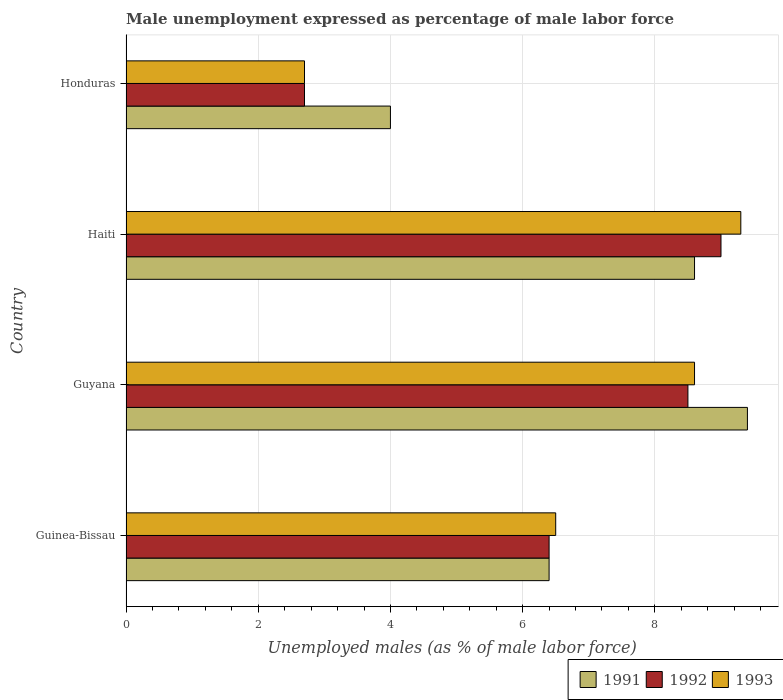How many different coloured bars are there?
Give a very brief answer. 3. How many groups of bars are there?
Offer a terse response. 4. Are the number of bars per tick equal to the number of legend labels?
Ensure brevity in your answer.  Yes. Are the number of bars on each tick of the Y-axis equal?
Offer a terse response. Yes. How many bars are there on the 2nd tick from the top?
Offer a very short reply. 3. How many bars are there on the 3rd tick from the bottom?
Offer a terse response. 3. What is the label of the 1st group of bars from the top?
Keep it short and to the point. Honduras. In how many cases, is the number of bars for a given country not equal to the number of legend labels?
Your answer should be very brief. 0. What is the unemployment in males in in 1992 in Guyana?
Give a very brief answer. 8.5. Across all countries, what is the maximum unemployment in males in in 1991?
Make the answer very short. 9.4. In which country was the unemployment in males in in 1991 maximum?
Your answer should be compact. Guyana. In which country was the unemployment in males in in 1993 minimum?
Ensure brevity in your answer.  Honduras. What is the total unemployment in males in in 1993 in the graph?
Ensure brevity in your answer.  27.1. What is the difference between the unemployment in males in in 1993 in Guinea-Bissau and that in Guyana?
Your answer should be very brief. -2.1. What is the difference between the unemployment in males in in 1991 in Guyana and the unemployment in males in in 1993 in Honduras?
Make the answer very short. 6.7. What is the average unemployment in males in in 1993 per country?
Give a very brief answer. 6.78. What is the difference between the unemployment in males in in 1993 and unemployment in males in in 1992 in Guyana?
Your response must be concise. 0.1. In how many countries, is the unemployment in males in in 1992 greater than 3.2 %?
Your answer should be compact. 3. What is the ratio of the unemployment in males in in 1993 in Haiti to that in Honduras?
Your answer should be compact. 3.44. Is the unemployment in males in in 1991 in Guinea-Bissau less than that in Honduras?
Offer a terse response. No. Is the difference between the unemployment in males in in 1993 in Haiti and Honduras greater than the difference between the unemployment in males in in 1992 in Haiti and Honduras?
Your answer should be compact. Yes. What is the difference between the highest and the lowest unemployment in males in in 1993?
Your answer should be compact. 6.6. Is the sum of the unemployment in males in in 1993 in Guinea-Bissau and Guyana greater than the maximum unemployment in males in in 1991 across all countries?
Keep it short and to the point. Yes. What does the 2nd bar from the top in Haiti represents?
Your answer should be compact. 1992. What does the 3rd bar from the bottom in Honduras represents?
Make the answer very short. 1993. Are all the bars in the graph horizontal?
Offer a very short reply. Yes. Are the values on the major ticks of X-axis written in scientific E-notation?
Offer a terse response. No. Does the graph contain grids?
Offer a terse response. Yes. Where does the legend appear in the graph?
Ensure brevity in your answer.  Bottom right. How many legend labels are there?
Keep it short and to the point. 3. What is the title of the graph?
Offer a very short reply. Male unemployment expressed as percentage of male labor force. What is the label or title of the X-axis?
Keep it short and to the point. Unemployed males (as % of male labor force). What is the label or title of the Y-axis?
Offer a very short reply. Country. What is the Unemployed males (as % of male labor force) in 1991 in Guinea-Bissau?
Make the answer very short. 6.4. What is the Unemployed males (as % of male labor force) of 1992 in Guinea-Bissau?
Keep it short and to the point. 6.4. What is the Unemployed males (as % of male labor force) of 1993 in Guinea-Bissau?
Offer a very short reply. 6.5. What is the Unemployed males (as % of male labor force) in 1991 in Guyana?
Your answer should be very brief. 9.4. What is the Unemployed males (as % of male labor force) of 1993 in Guyana?
Ensure brevity in your answer.  8.6. What is the Unemployed males (as % of male labor force) of 1991 in Haiti?
Provide a short and direct response. 8.6. What is the Unemployed males (as % of male labor force) in 1992 in Haiti?
Your response must be concise. 9. What is the Unemployed males (as % of male labor force) of 1993 in Haiti?
Ensure brevity in your answer.  9.3. What is the Unemployed males (as % of male labor force) of 1992 in Honduras?
Provide a succinct answer. 2.7. What is the Unemployed males (as % of male labor force) in 1993 in Honduras?
Offer a terse response. 2.7. Across all countries, what is the maximum Unemployed males (as % of male labor force) in 1991?
Keep it short and to the point. 9.4. Across all countries, what is the maximum Unemployed males (as % of male labor force) of 1992?
Ensure brevity in your answer.  9. Across all countries, what is the maximum Unemployed males (as % of male labor force) in 1993?
Keep it short and to the point. 9.3. Across all countries, what is the minimum Unemployed males (as % of male labor force) in 1992?
Your response must be concise. 2.7. Across all countries, what is the minimum Unemployed males (as % of male labor force) of 1993?
Your response must be concise. 2.7. What is the total Unemployed males (as % of male labor force) in 1991 in the graph?
Your answer should be compact. 28.4. What is the total Unemployed males (as % of male labor force) in 1992 in the graph?
Provide a short and direct response. 26.6. What is the total Unemployed males (as % of male labor force) of 1993 in the graph?
Offer a very short reply. 27.1. What is the difference between the Unemployed males (as % of male labor force) of 1991 in Guinea-Bissau and that in Guyana?
Ensure brevity in your answer.  -3. What is the difference between the Unemployed males (as % of male labor force) in 1992 in Guinea-Bissau and that in Guyana?
Make the answer very short. -2.1. What is the difference between the Unemployed males (as % of male labor force) in 1991 in Guinea-Bissau and that in Haiti?
Provide a succinct answer. -2.2. What is the difference between the Unemployed males (as % of male labor force) in 1991 in Guinea-Bissau and that in Honduras?
Offer a terse response. 2.4. What is the difference between the Unemployed males (as % of male labor force) of 1992 in Guinea-Bissau and that in Honduras?
Provide a short and direct response. 3.7. What is the difference between the Unemployed males (as % of male labor force) in 1991 in Haiti and that in Honduras?
Your response must be concise. 4.6. What is the difference between the Unemployed males (as % of male labor force) in 1992 in Haiti and that in Honduras?
Provide a short and direct response. 6.3. What is the difference between the Unemployed males (as % of male labor force) of 1993 in Haiti and that in Honduras?
Provide a short and direct response. 6.6. What is the difference between the Unemployed males (as % of male labor force) in 1992 in Guinea-Bissau and the Unemployed males (as % of male labor force) in 1993 in Guyana?
Your answer should be very brief. -2.2. What is the difference between the Unemployed males (as % of male labor force) of 1991 in Guinea-Bissau and the Unemployed males (as % of male labor force) of 1992 in Haiti?
Your response must be concise. -2.6. What is the difference between the Unemployed males (as % of male labor force) in 1992 in Guinea-Bissau and the Unemployed males (as % of male labor force) in 1993 in Haiti?
Offer a very short reply. -2.9. What is the difference between the Unemployed males (as % of male labor force) in 1992 in Guinea-Bissau and the Unemployed males (as % of male labor force) in 1993 in Honduras?
Offer a very short reply. 3.7. What is the difference between the Unemployed males (as % of male labor force) in 1991 in Guyana and the Unemployed males (as % of male labor force) in 1992 in Haiti?
Your answer should be compact. 0.4. What is the difference between the Unemployed males (as % of male labor force) in 1991 in Guyana and the Unemployed males (as % of male labor force) in 1993 in Haiti?
Offer a very short reply. 0.1. What is the difference between the Unemployed males (as % of male labor force) in 1991 in Guyana and the Unemployed males (as % of male labor force) in 1993 in Honduras?
Keep it short and to the point. 6.7. What is the difference between the Unemployed males (as % of male labor force) of 1992 in Guyana and the Unemployed males (as % of male labor force) of 1993 in Honduras?
Offer a very short reply. 5.8. What is the average Unemployed males (as % of male labor force) in 1991 per country?
Keep it short and to the point. 7.1. What is the average Unemployed males (as % of male labor force) of 1992 per country?
Your answer should be compact. 6.65. What is the average Unemployed males (as % of male labor force) of 1993 per country?
Keep it short and to the point. 6.78. What is the difference between the Unemployed males (as % of male labor force) of 1991 and Unemployed males (as % of male labor force) of 1992 in Guinea-Bissau?
Your answer should be compact. 0. What is the difference between the Unemployed males (as % of male labor force) of 1991 and Unemployed males (as % of male labor force) of 1993 in Guyana?
Your response must be concise. 0.8. What is the difference between the Unemployed males (as % of male labor force) in 1992 and Unemployed males (as % of male labor force) in 1993 in Guyana?
Offer a very short reply. -0.1. What is the difference between the Unemployed males (as % of male labor force) of 1991 and Unemployed males (as % of male labor force) of 1993 in Haiti?
Offer a very short reply. -0.7. What is the difference between the Unemployed males (as % of male labor force) in 1992 and Unemployed males (as % of male labor force) in 1993 in Haiti?
Your answer should be very brief. -0.3. What is the difference between the Unemployed males (as % of male labor force) in 1991 and Unemployed males (as % of male labor force) in 1992 in Honduras?
Your response must be concise. 1.3. What is the difference between the Unemployed males (as % of male labor force) in 1991 and Unemployed males (as % of male labor force) in 1993 in Honduras?
Offer a terse response. 1.3. What is the difference between the Unemployed males (as % of male labor force) of 1992 and Unemployed males (as % of male labor force) of 1993 in Honduras?
Keep it short and to the point. 0. What is the ratio of the Unemployed males (as % of male labor force) of 1991 in Guinea-Bissau to that in Guyana?
Give a very brief answer. 0.68. What is the ratio of the Unemployed males (as % of male labor force) of 1992 in Guinea-Bissau to that in Guyana?
Make the answer very short. 0.75. What is the ratio of the Unemployed males (as % of male labor force) in 1993 in Guinea-Bissau to that in Guyana?
Your answer should be compact. 0.76. What is the ratio of the Unemployed males (as % of male labor force) in 1991 in Guinea-Bissau to that in Haiti?
Ensure brevity in your answer.  0.74. What is the ratio of the Unemployed males (as % of male labor force) in 1992 in Guinea-Bissau to that in Haiti?
Offer a very short reply. 0.71. What is the ratio of the Unemployed males (as % of male labor force) in 1993 in Guinea-Bissau to that in Haiti?
Offer a very short reply. 0.7. What is the ratio of the Unemployed males (as % of male labor force) of 1991 in Guinea-Bissau to that in Honduras?
Your answer should be compact. 1.6. What is the ratio of the Unemployed males (as % of male labor force) of 1992 in Guinea-Bissau to that in Honduras?
Ensure brevity in your answer.  2.37. What is the ratio of the Unemployed males (as % of male labor force) in 1993 in Guinea-Bissau to that in Honduras?
Give a very brief answer. 2.41. What is the ratio of the Unemployed males (as % of male labor force) of 1991 in Guyana to that in Haiti?
Provide a short and direct response. 1.09. What is the ratio of the Unemployed males (as % of male labor force) of 1993 in Guyana to that in Haiti?
Make the answer very short. 0.92. What is the ratio of the Unemployed males (as % of male labor force) in 1991 in Guyana to that in Honduras?
Your answer should be very brief. 2.35. What is the ratio of the Unemployed males (as % of male labor force) in 1992 in Guyana to that in Honduras?
Offer a terse response. 3.15. What is the ratio of the Unemployed males (as % of male labor force) of 1993 in Guyana to that in Honduras?
Your answer should be very brief. 3.19. What is the ratio of the Unemployed males (as % of male labor force) in 1991 in Haiti to that in Honduras?
Make the answer very short. 2.15. What is the ratio of the Unemployed males (as % of male labor force) in 1992 in Haiti to that in Honduras?
Offer a terse response. 3.33. What is the ratio of the Unemployed males (as % of male labor force) of 1993 in Haiti to that in Honduras?
Offer a terse response. 3.44. What is the difference between the highest and the second highest Unemployed males (as % of male labor force) in 1993?
Your answer should be very brief. 0.7. What is the difference between the highest and the lowest Unemployed males (as % of male labor force) of 1991?
Make the answer very short. 5.4. What is the difference between the highest and the lowest Unemployed males (as % of male labor force) in 1992?
Ensure brevity in your answer.  6.3. What is the difference between the highest and the lowest Unemployed males (as % of male labor force) in 1993?
Ensure brevity in your answer.  6.6. 